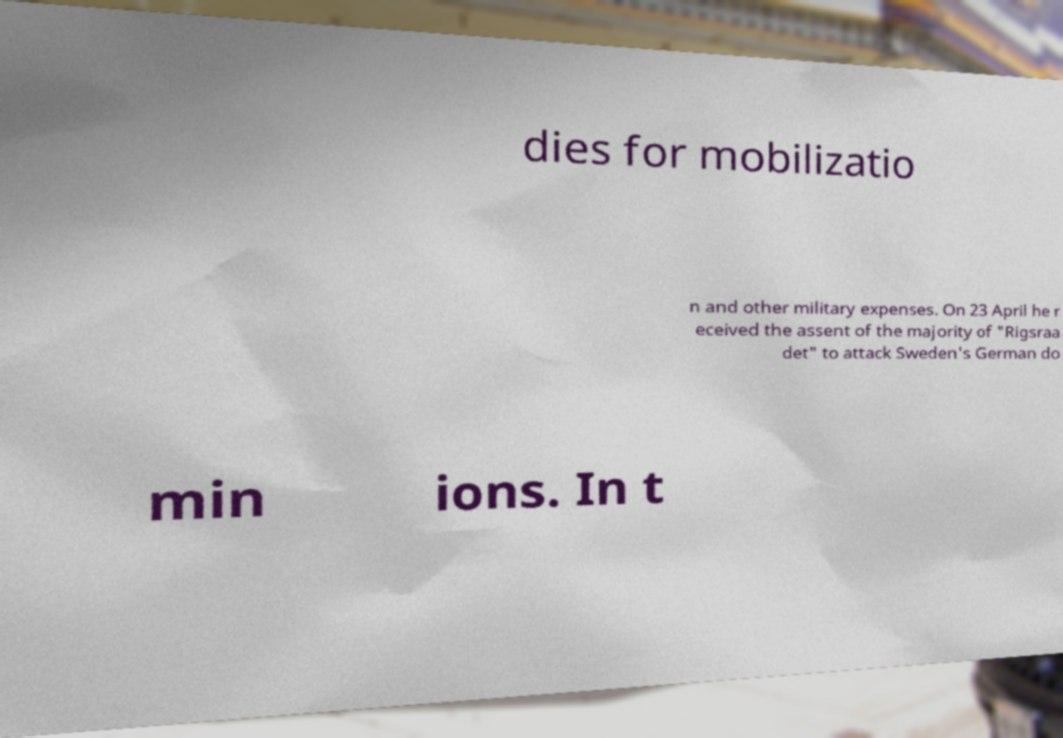What messages or text are displayed in this image? I need them in a readable, typed format. dies for mobilizatio n and other military expenses. On 23 April he r eceived the assent of the majority of "Rigsraa det" to attack Sweden's German do min ions. In t 